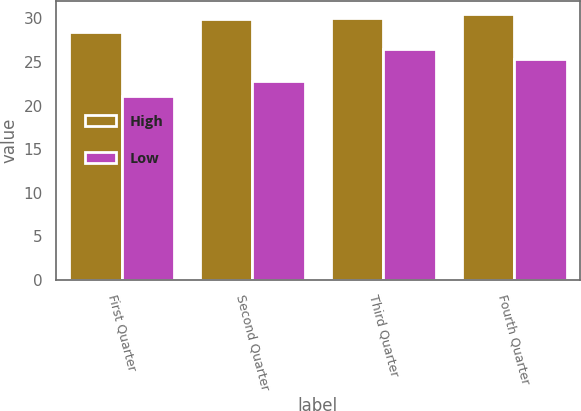Convert chart to OTSL. <chart><loc_0><loc_0><loc_500><loc_500><stacked_bar_chart><ecel><fcel>First Quarter<fcel>Second Quarter<fcel>Third Quarter<fcel>Fourth Quarter<nl><fcel>High<fcel>28.43<fcel>29.97<fcel>30<fcel>30.47<nl><fcel>Low<fcel>21.08<fcel>22.77<fcel>26.5<fcel>25.33<nl></chart> 